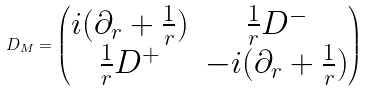Convert formula to latex. <formula><loc_0><loc_0><loc_500><loc_500>D _ { M } = \begin{pmatrix} i ( \partial _ { r } + \frac { 1 } { r } ) & \frac { 1 } { r } D ^ { - } \\ \frac { 1 } { r } D ^ { + } & - i ( \partial _ { r } + \frac { 1 } { r } ) \end{pmatrix}</formula> 